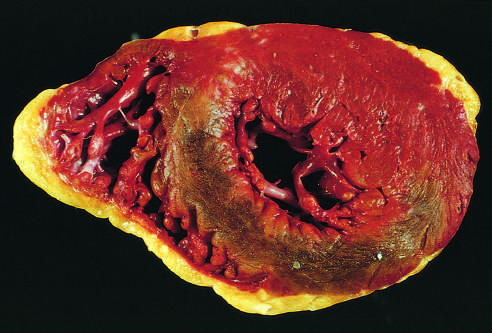where is the posterior wall?
Answer the question using a single word or phrase. At the top 